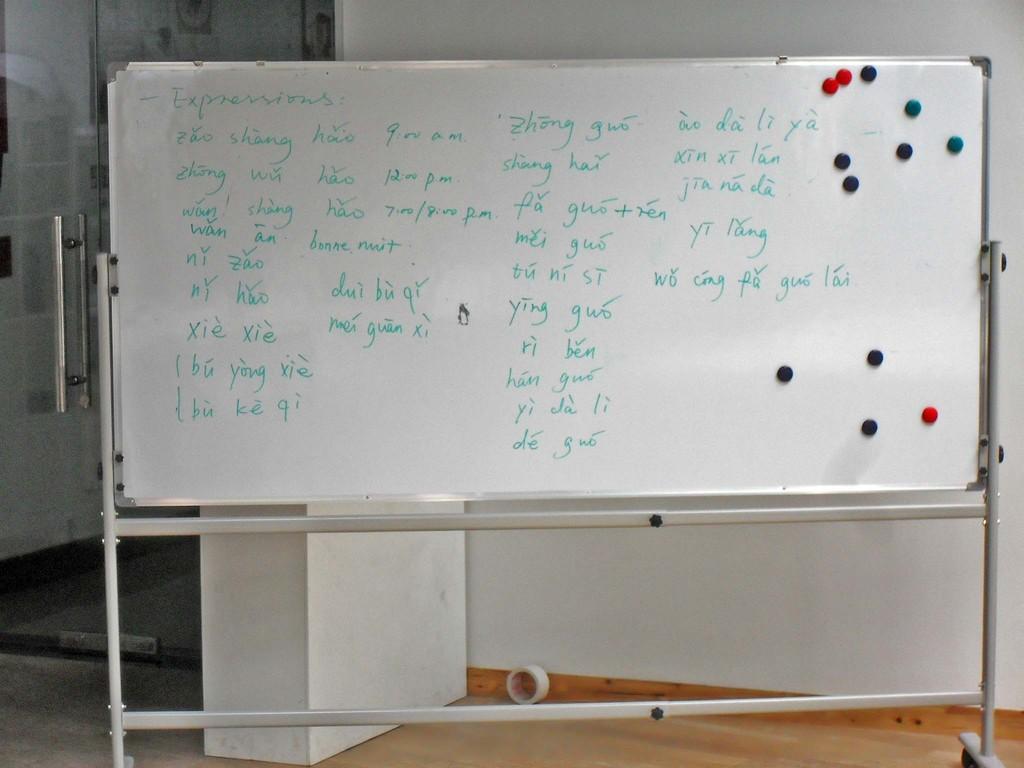What is the main topic of the whiteboard lesson?
Your answer should be very brief. Expressions. 